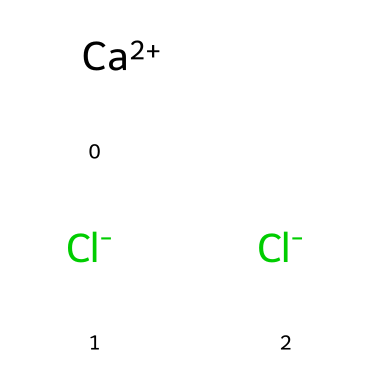What is the total number of atoms in this compound? The compound consists of one calcium atom and two chlorine atoms. Therefore, the total number of atoms is three.
Answer: 3 What is the charge of calcium in this structure? The SMILES representation indicates that calcium is denoted as [Ca+2], indicating it has a +2 charge.
Answer: +2 How many chlorine atoms are present in the chemical structure? The structure contains two chlorine atoms, as indicated by two occurrences of [Cl-] in the SMILES representation.
Answer: 2 What type of chemical bond exists between calcium and chlorine? In this ionic compound, the bond between calcium and chlorine is an ionic bond, which occurs due to the transfer of electrons from calcium to chlorine, resulting in charged ions.
Answer: ionic bond Is calcium chloride a solid or a liquid at room temperature? Calcium chloride is typically a solid at room temperature as it is a common ionic compound that forms a crystalline structure.
Answer: solid What role does calcium chloride play as an electrolyte? Calcium chloride dissociates in solution into calcium and chloride ions, allowing it to conduct electricity and serve as an electrolyte.
Answer: electrolyte 